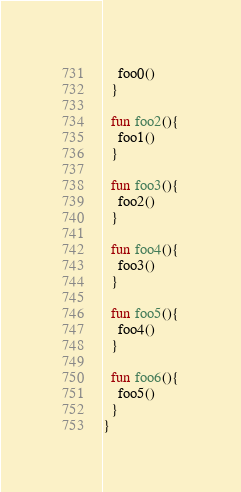<code> <loc_0><loc_0><loc_500><loc_500><_Kotlin_>    foo0()
  }

  fun foo2(){
    foo1()
  }

  fun foo3(){
    foo2()
  }

  fun foo4(){
    foo3()
  }

  fun foo5(){
    foo4()
  }

  fun foo6(){
    foo5()
  }
}</code> 